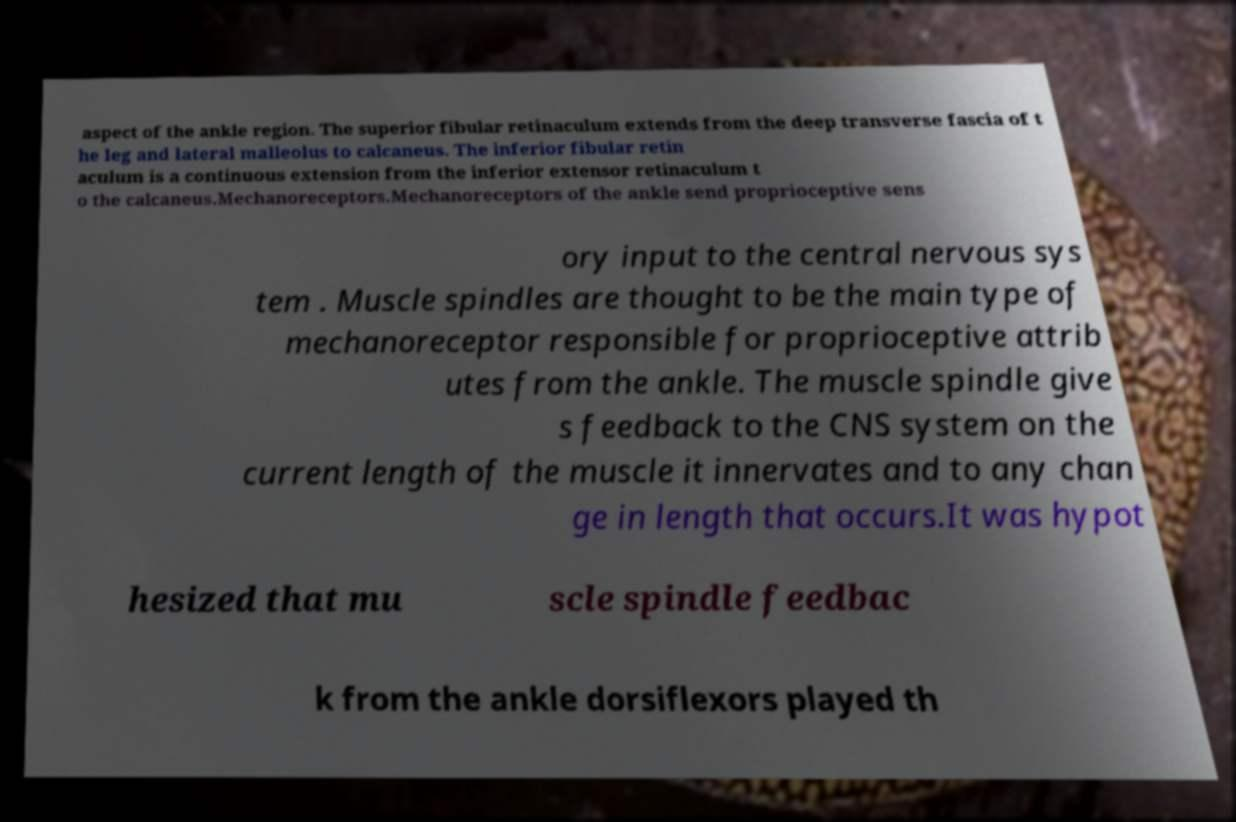What messages or text are displayed in this image? I need them in a readable, typed format. aspect of the ankle region. The superior fibular retinaculum extends from the deep transverse fascia of t he leg and lateral malleolus to calcaneus. The inferior fibular retin aculum is a continuous extension from the inferior extensor retinaculum t o the calcaneus.Mechanoreceptors.Mechanoreceptors of the ankle send proprioceptive sens ory input to the central nervous sys tem . Muscle spindles are thought to be the main type of mechanoreceptor responsible for proprioceptive attrib utes from the ankle. The muscle spindle give s feedback to the CNS system on the current length of the muscle it innervates and to any chan ge in length that occurs.It was hypot hesized that mu scle spindle feedbac k from the ankle dorsiflexors played th 